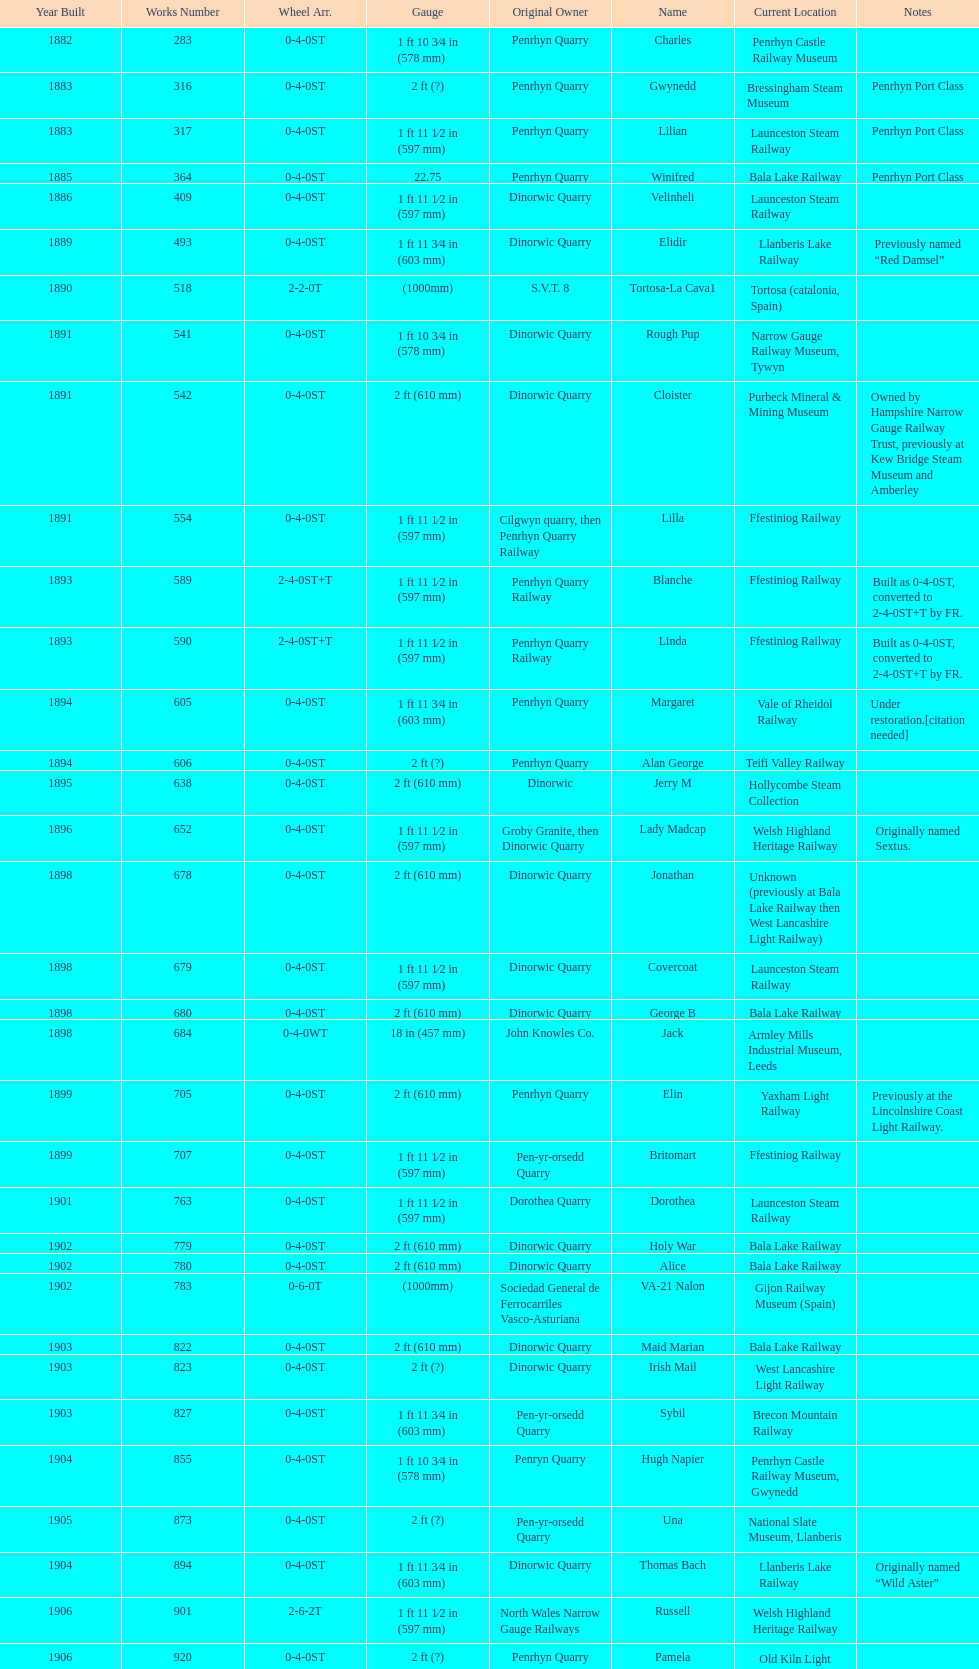Aside from 316, what was the other works number used in 1883? 317. 